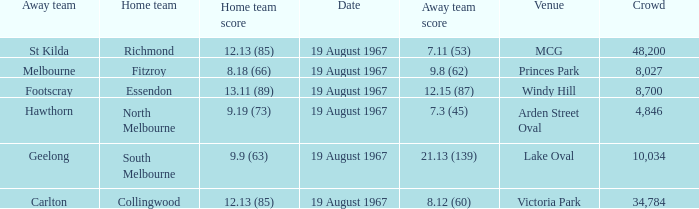What did the away team score when they were playing collingwood? 8.12 (60). 